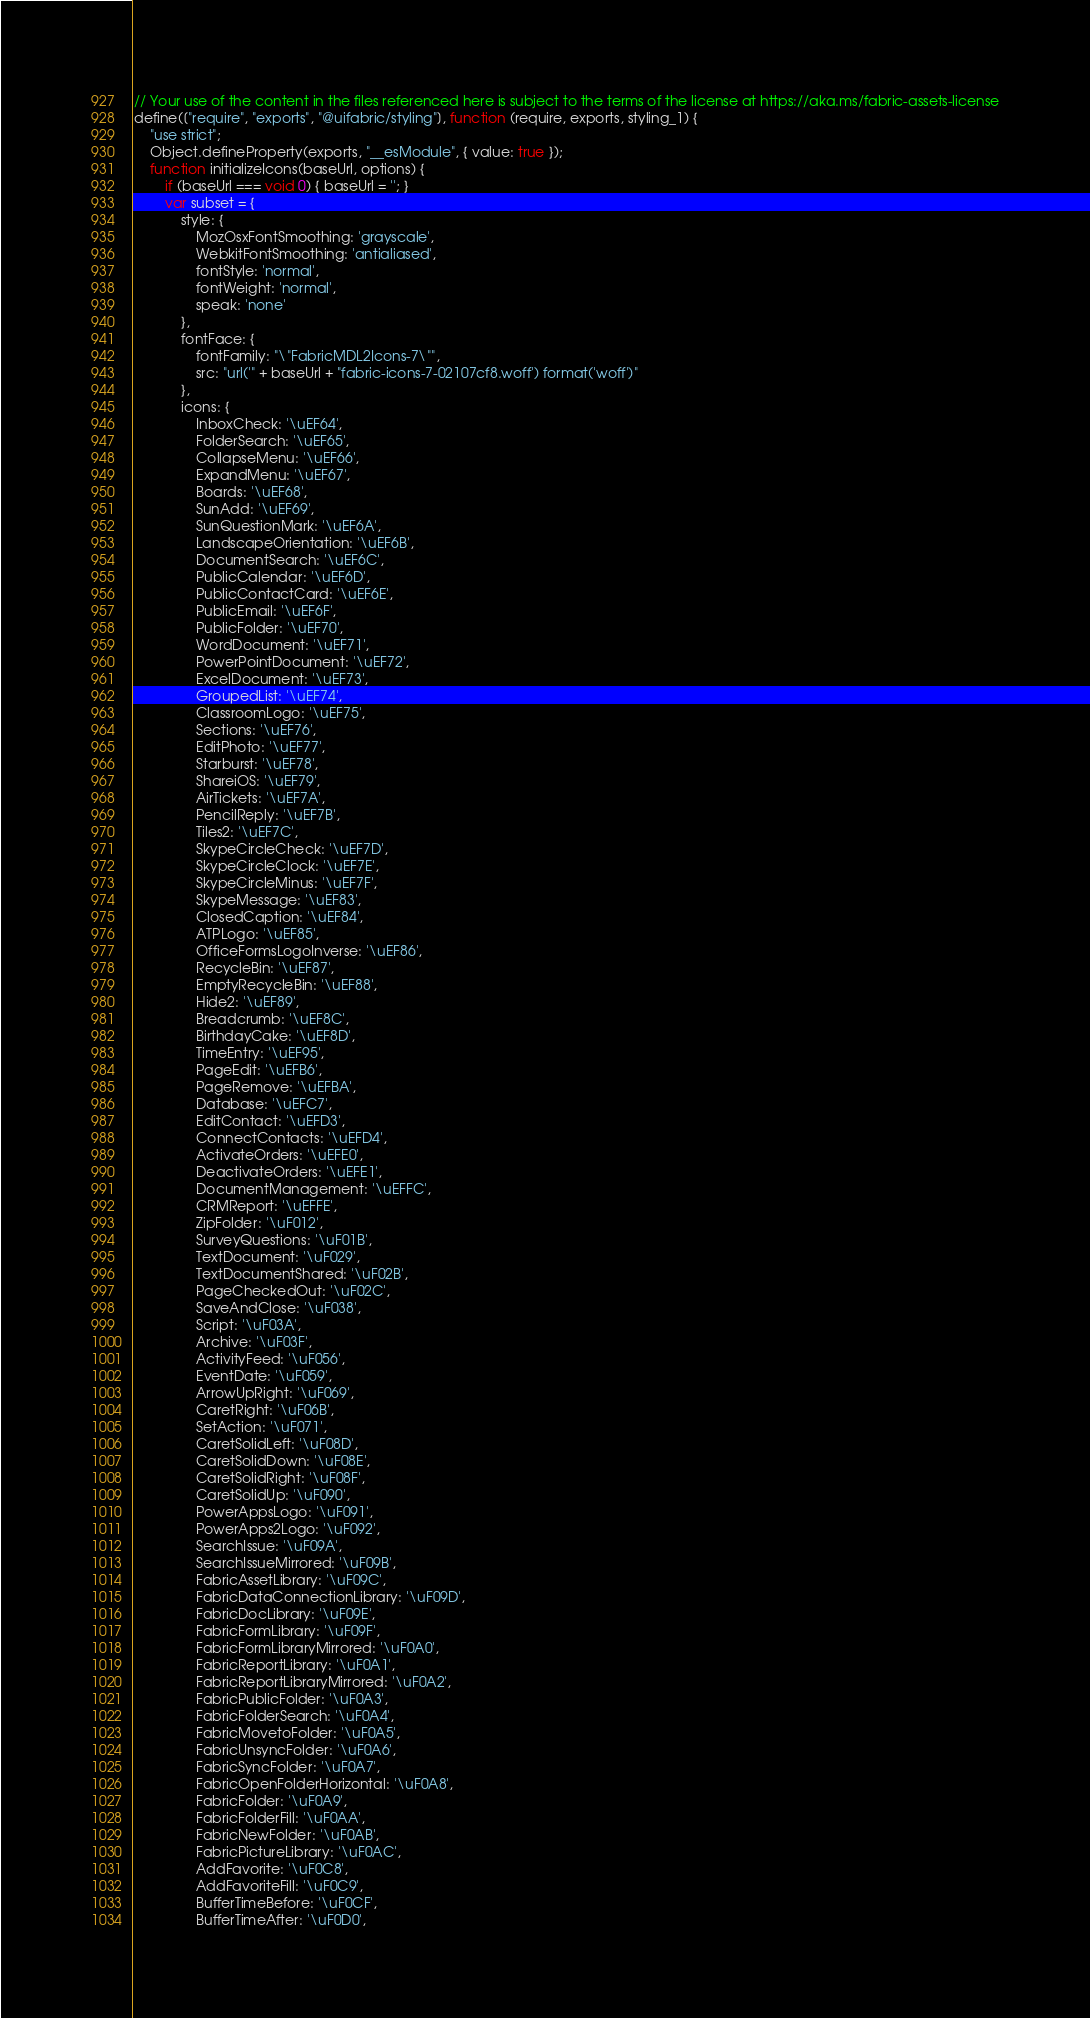Convert code to text. <code><loc_0><loc_0><loc_500><loc_500><_JavaScript_>// Your use of the content in the files referenced here is subject to the terms of the license at https://aka.ms/fabric-assets-license
define(["require", "exports", "@uifabric/styling"], function (require, exports, styling_1) {
    "use strict";
    Object.defineProperty(exports, "__esModule", { value: true });
    function initializeIcons(baseUrl, options) {
        if (baseUrl === void 0) { baseUrl = ''; }
        var subset = {
            style: {
                MozOsxFontSmoothing: 'grayscale',
                WebkitFontSmoothing: 'antialiased',
                fontStyle: 'normal',
                fontWeight: 'normal',
                speak: 'none'
            },
            fontFace: {
                fontFamily: "\"FabricMDL2Icons-7\"",
                src: "url('" + baseUrl + "fabric-icons-7-02107cf8.woff') format('woff')"
            },
            icons: {
                InboxCheck: '\uEF64',
                FolderSearch: '\uEF65',
                CollapseMenu: '\uEF66',
                ExpandMenu: '\uEF67',
                Boards: '\uEF68',
                SunAdd: '\uEF69',
                SunQuestionMark: '\uEF6A',
                LandscapeOrientation: '\uEF6B',
                DocumentSearch: '\uEF6C',
                PublicCalendar: '\uEF6D',
                PublicContactCard: '\uEF6E',
                PublicEmail: '\uEF6F',
                PublicFolder: '\uEF70',
                WordDocument: '\uEF71',
                PowerPointDocument: '\uEF72',
                ExcelDocument: '\uEF73',
                GroupedList: '\uEF74',
                ClassroomLogo: '\uEF75',
                Sections: '\uEF76',
                EditPhoto: '\uEF77',
                Starburst: '\uEF78',
                ShareiOS: '\uEF79',
                AirTickets: '\uEF7A',
                PencilReply: '\uEF7B',
                Tiles2: '\uEF7C',
                SkypeCircleCheck: '\uEF7D',
                SkypeCircleClock: '\uEF7E',
                SkypeCircleMinus: '\uEF7F',
                SkypeMessage: '\uEF83',
                ClosedCaption: '\uEF84',
                ATPLogo: '\uEF85',
                OfficeFormsLogoInverse: '\uEF86',
                RecycleBin: '\uEF87',
                EmptyRecycleBin: '\uEF88',
                Hide2: '\uEF89',
                Breadcrumb: '\uEF8C',
                BirthdayCake: '\uEF8D',
                TimeEntry: '\uEF95',
                PageEdit: '\uEFB6',
                PageRemove: '\uEFBA',
                Database: '\uEFC7',
                EditContact: '\uEFD3',
                ConnectContacts: '\uEFD4',
                ActivateOrders: '\uEFE0',
                DeactivateOrders: '\uEFE1',
                DocumentManagement: '\uEFFC',
                CRMReport: '\uEFFE',
                ZipFolder: '\uF012',
                SurveyQuestions: '\uF01B',
                TextDocument: '\uF029',
                TextDocumentShared: '\uF02B',
                PageCheckedOut: '\uF02C',
                SaveAndClose: '\uF038',
                Script: '\uF03A',
                Archive: '\uF03F',
                ActivityFeed: '\uF056',
                EventDate: '\uF059',
                ArrowUpRight: '\uF069',
                CaretRight: '\uF06B',
                SetAction: '\uF071',
                CaretSolidLeft: '\uF08D',
                CaretSolidDown: '\uF08E',
                CaretSolidRight: '\uF08F',
                CaretSolidUp: '\uF090',
                PowerAppsLogo: '\uF091',
                PowerApps2Logo: '\uF092',
                SearchIssue: '\uF09A',
                SearchIssueMirrored: '\uF09B',
                FabricAssetLibrary: '\uF09C',
                FabricDataConnectionLibrary: '\uF09D',
                FabricDocLibrary: '\uF09E',
                FabricFormLibrary: '\uF09F',
                FabricFormLibraryMirrored: '\uF0A0',
                FabricReportLibrary: '\uF0A1',
                FabricReportLibraryMirrored: '\uF0A2',
                FabricPublicFolder: '\uF0A3',
                FabricFolderSearch: '\uF0A4',
                FabricMovetoFolder: '\uF0A5',
                FabricUnsyncFolder: '\uF0A6',
                FabricSyncFolder: '\uF0A7',
                FabricOpenFolderHorizontal: '\uF0A8',
                FabricFolder: '\uF0A9',
                FabricFolderFill: '\uF0AA',
                FabricNewFolder: '\uF0AB',
                FabricPictureLibrary: '\uF0AC',
                AddFavorite: '\uF0C8',
                AddFavoriteFill: '\uF0C9',
                BufferTimeBefore: '\uF0CF',
                BufferTimeAfter: '\uF0D0',</code> 